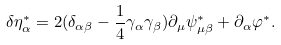Convert formula to latex. <formula><loc_0><loc_0><loc_500><loc_500>\delta \eta _ { \alpha } ^ { * } = 2 ( \delta _ { \alpha \beta } - \frac { 1 } { 4 } \gamma _ { \alpha } \gamma _ { \beta } ) \partial _ { \mu } \psi _ { \mu \beta } ^ { * } + \partial _ { \alpha } \varphi ^ { * } .</formula> 